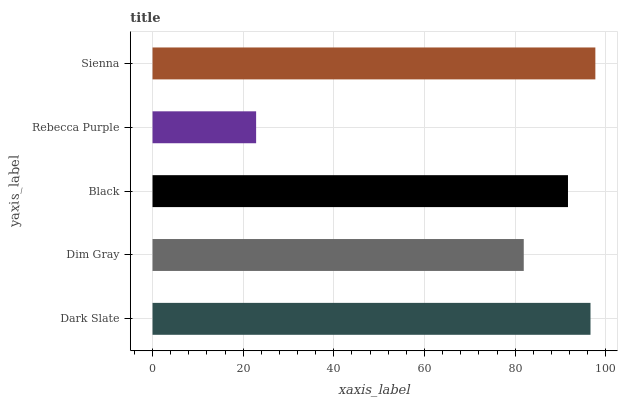Is Rebecca Purple the minimum?
Answer yes or no. Yes. Is Sienna the maximum?
Answer yes or no. Yes. Is Dim Gray the minimum?
Answer yes or no. No. Is Dim Gray the maximum?
Answer yes or no. No. Is Dark Slate greater than Dim Gray?
Answer yes or no. Yes. Is Dim Gray less than Dark Slate?
Answer yes or no. Yes. Is Dim Gray greater than Dark Slate?
Answer yes or no. No. Is Dark Slate less than Dim Gray?
Answer yes or no. No. Is Black the high median?
Answer yes or no. Yes. Is Black the low median?
Answer yes or no. Yes. Is Rebecca Purple the high median?
Answer yes or no. No. Is Dim Gray the low median?
Answer yes or no. No. 